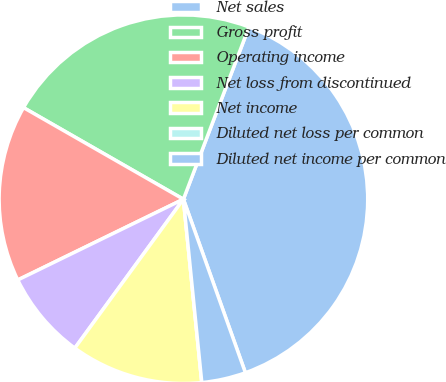<chart> <loc_0><loc_0><loc_500><loc_500><pie_chart><fcel>Net sales<fcel>Gross profit<fcel>Operating income<fcel>Net loss from discontinued<fcel>Net income<fcel>Diluted net loss per common<fcel>Diluted net income per common<nl><fcel>38.75%<fcel>22.51%<fcel>15.5%<fcel>7.75%<fcel>11.62%<fcel>0.0%<fcel>3.87%<nl></chart> 